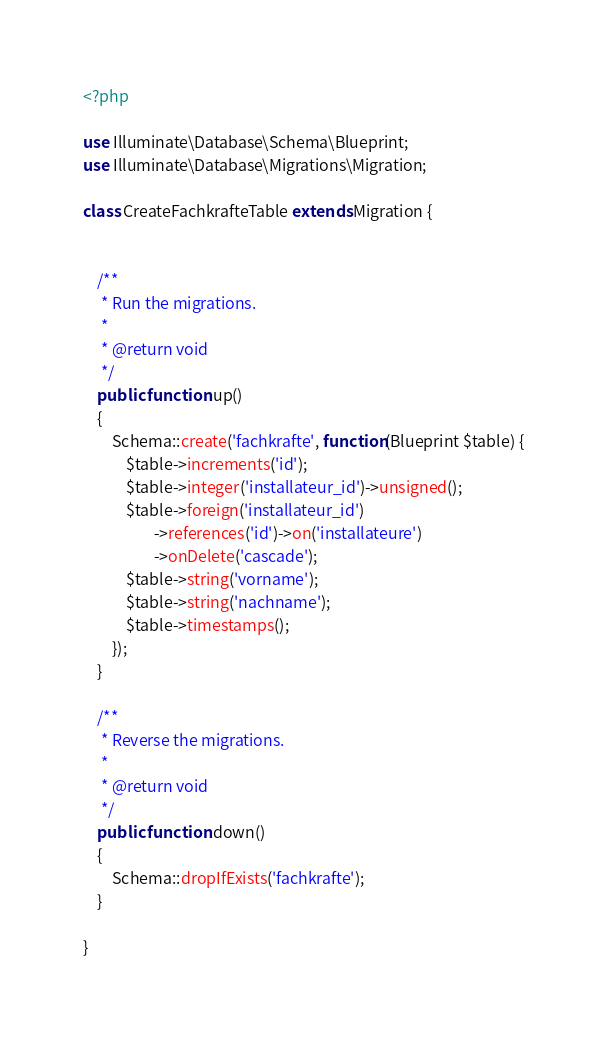Convert code to text. <code><loc_0><loc_0><loc_500><loc_500><_PHP_><?php

use Illuminate\Database\Schema\Blueprint;
use Illuminate\Database\Migrations\Migration;

class CreateFachkrafteTable extends Migration {


	/**
	 * Run the migrations.
	 *
	 * @return void
	 */
    public function up()
    {
        Schema::create('fachkrafte', function(Blueprint $table) {
            $table->increments('id');
            $table->integer('installateur_id')->unsigned();
            $table->foreign('installateur_id')
                    ->references('id')->on('installateure')
                    ->onDelete('cascade');
            $table->string('vorname');
            $table->string('nachname');
            $table->timestamps();
        });
    }

    /**
     * Reverse the migrations.
     *
     * @return void
     */
    public function down()
    {
        Schema::dropIfExists('fachkrafte');
    }

}
</code> 